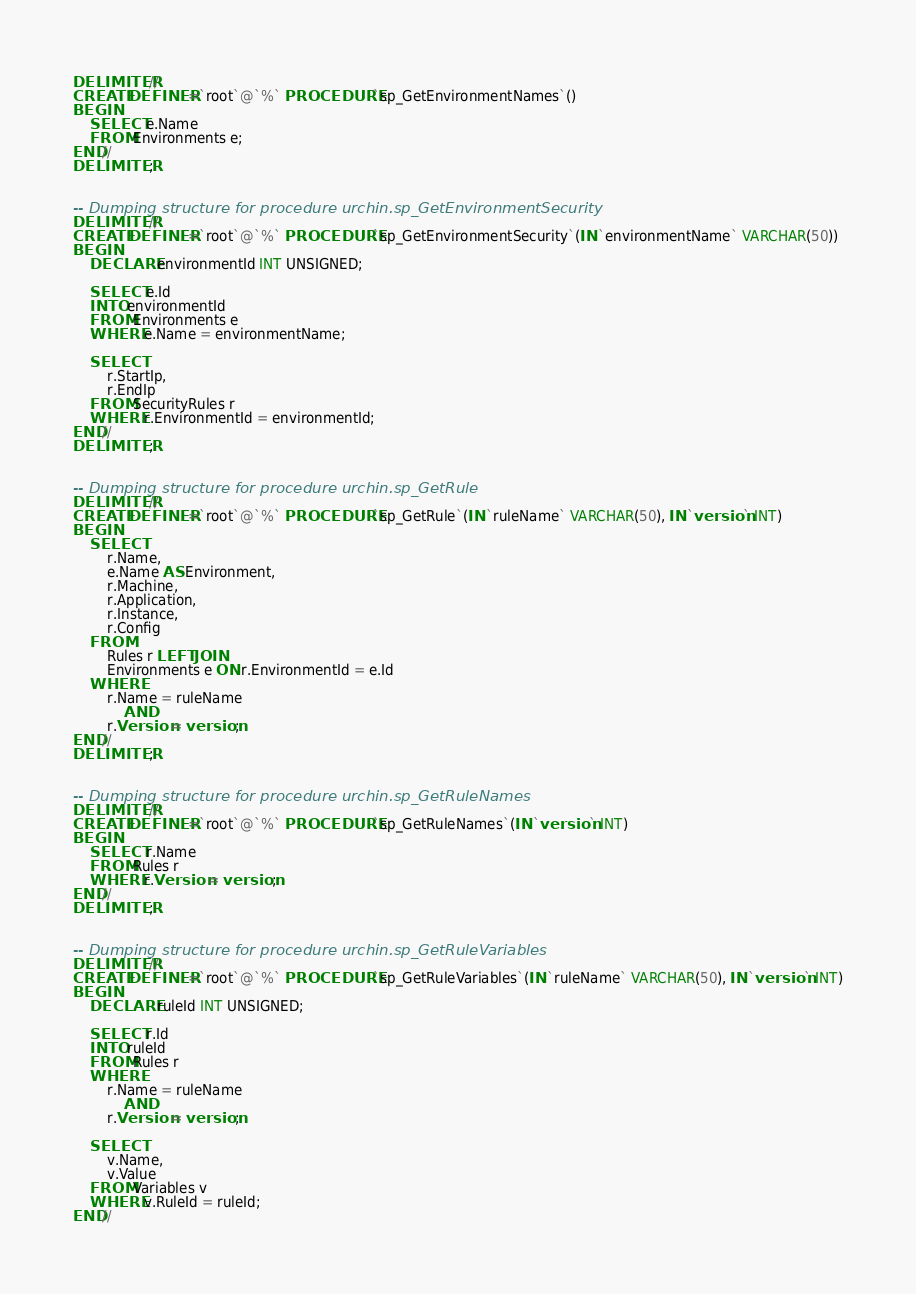<code> <loc_0><loc_0><loc_500><loc_500><_SQL_>DELIMITER //
CREATE DEFINER=`root`@`%` PROCEDURE `sp_GetEnvironmentNames`()
BEGIN
	SELECT e.Name
	FROM Environments e;
END//
DELIMITER ;


-- Dumping structure for procedure urchin.sp_GetEnvironmentSecurity
DELIMITER //
CREATE DEFINER=`root`@`%` PROCEDURE `sp_GetEnvironmentSecurity`(IN `environmentName` VARCHAR(50))
BEGIN
	DECLARE environmentId INT UNSIGNED;
	
	SELECT e.Id
	INTO environmentId
	FROM Environments e
	WHERE e.Name = environmentName;
	
	SELECT 
		r.StartIp,
		r.EndIp
	FROM SecurityRules r
	WHERE r.EnvironmentId = environmentId;
END//
DELIMITER ;


-- Dumping structure for procedure urchin.sp_GetRule
DELIMITER //
CREATE DEFINER=`root`@`%` PROCEDURE `sp_GetRule`(IN `ruleName` VARCHAR(50), IN `version` INT)
BEGIN
	SELECT
		r.Name,
		e.Name AS Environment,
		r.Machine,
		r.Application,
		r.Instance,
		r.Config
	FROM 
		Rules r LEFT JOIN
		Environments e ON r.EnvironmentId = e.Id
	WHERE 
		r.Name = ruleName
			AND
		r.Version = version;
END//
DELIMITER ;


-- Dumping structure for procedure urchin.sp_GetRuleNames
DELIMITER //
CREATE DEFINER=`root`@`%` PROCEDURE `sp_GetRuleNames`(IN `version` INT)
BEGIN
	SELECT r.Name
	FROM Rules r
	WHERE r.Version = version;
END//
DELIMITER ;


-- Dumping structure for procedure urchin.sp_GetRuleVariables
DELIMITER //
CREATE DEFINER=`root`@`%` PROCEDURE `sp_GetRuleVariables`(IN `ruleName` VARCHAR(50), IN `version` INT)
BEGIN
	DECLARE ruleId INT UNSIGNED;
	
	SELECT r.Id
	INTO ruleId
	FROM Rules r
	WHERE 
		r.Name = ruleName
			AND
		r.Version = version;

	SELECT 
		v.Name,
		v.Value
	FROM Variables v
	WHERE v.RuleId = ruleId;
END//</code> 